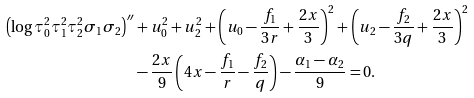<formula> <loc_0><loc_0><loc_500><loc_500>\left ( \log \tau _ { 0 } ^ { 2 } \tau _ { 1 } ^ { 2 } \tau _ { 2 } ^ { 2 } \sigma _ { 1 } \sigma _ { 2 } \right ) ^ { \prime \prime } & + u _ { 0 } ^ { 2 } + u _ { 2 } ^ { 2 } + \left ( u _ { 0 } - \frac { f _ { 1 } } { 3 r } + \frac { 2 x } { 3 } \right ) ^ { 2 } + \left ( u _ { 2 } - \frac { f _ { 2 } } { 3 q } + \frac { 2 x } { 3 } \right ) ^ { 2 } \\ & - \frac { 2 x } { 9 } \left ( 4 x - \frac { f _ { 1 } } { r } - \frac { f _ { 2 } } { q } \right ) - \frac { \alpha _ { 1 } - \alpha _ { 2 } } { 9 } = 0 .</formula> 